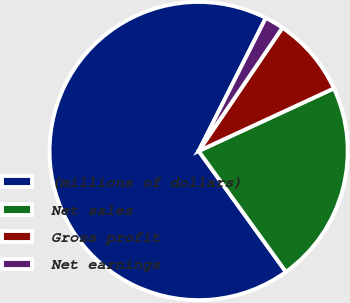<chart> <loc_0><loc_0><loc_500><loc_500><pie_chart><fcel>(millions of dollars)<fcel>Net sales<fcel>Gross profit<fcel>Net earnings<nl><fcel>67.39%<fcel>21.95%<fcel>8.6%<fcel>2.06%<nl></chart> 